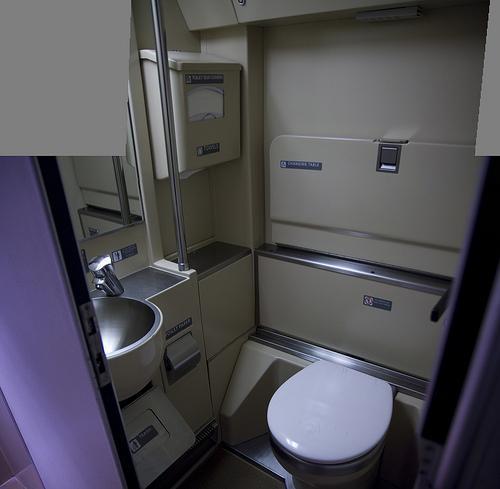How many toilet seats are up?
Give a very brief answer. 0. 